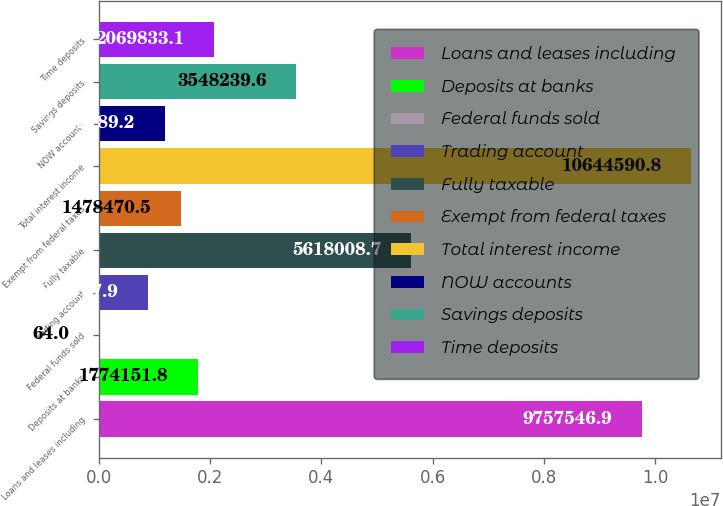Convert chart. <chart><loc_0><loc_0><loc_500><loc_500><bar_chart><fcel>Loans and leases including<fcel>Deposits at banks<fcel>Federal funds sold<fcel>Trading account<fcel>Fully taxable<fcel>Exempt from federal taxes<fcel>Total interest income<fcel>NOW accounts<fcel>Savings deposits<fcel>Time deposits<nl><fcel>9.75755e+06<fcel>1.77415e+06<fcel>64<fcel>887108<fcel>5.61801e+06<fcel>1.47847e+06<fcel>1.06446e+07<fcel>1.18279e+06<fcel>3.54824e+06<fcel>2.06983e+06<nl></chart> 